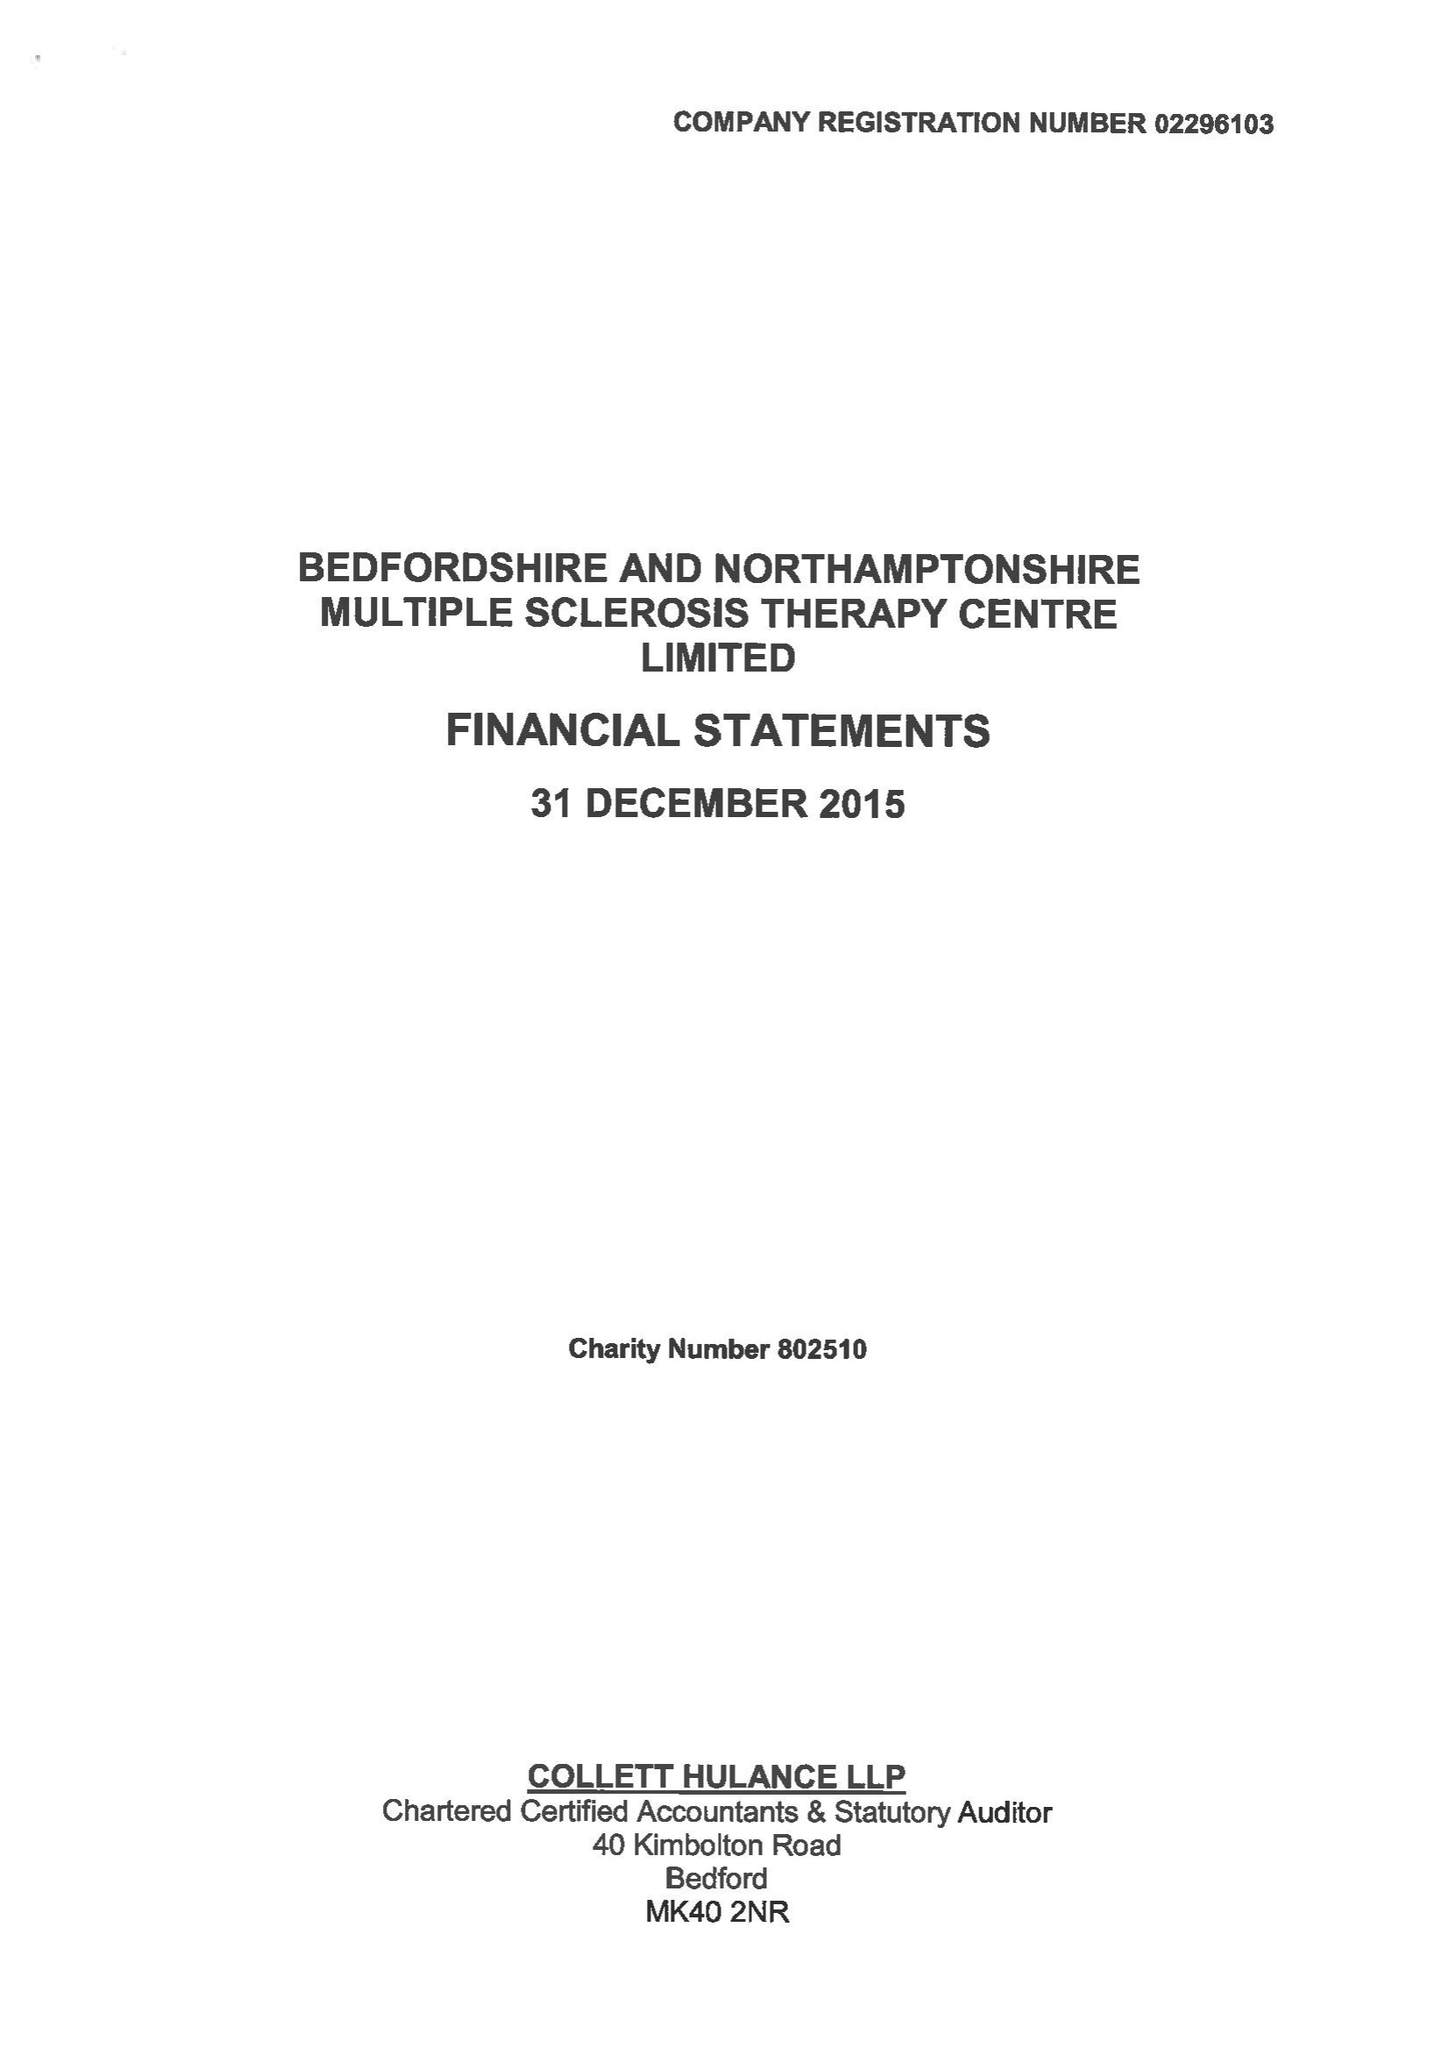What is the value for the income_annually_in_british_pounds?
Answer the question using a single word or phrase. 374848.00 